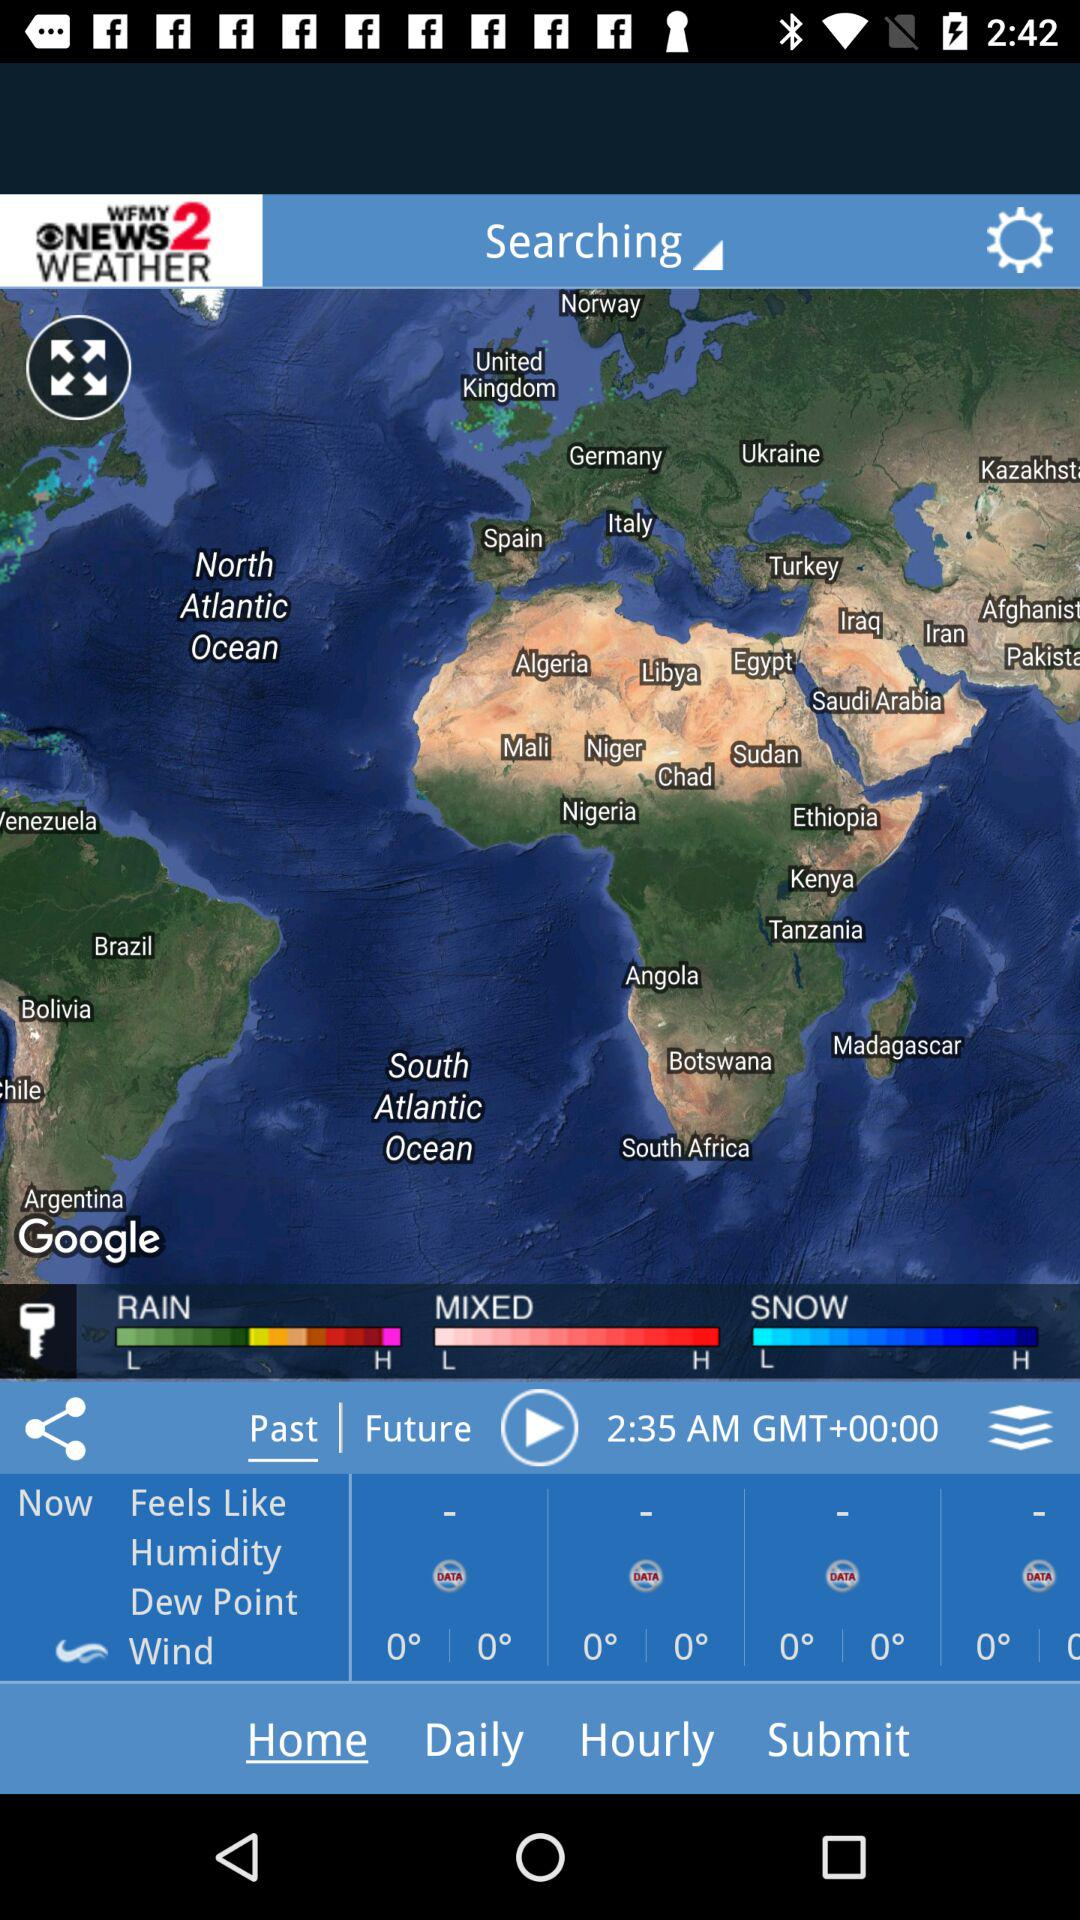How many types of weather are currently happening?
Answer the question using a single word or phrase. 3 